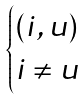<formula> <loc_0><loc_0><loc_500><loc_500>\begin{cases} ( i , u ) \\ i \neq u \end{cases}</formula> 